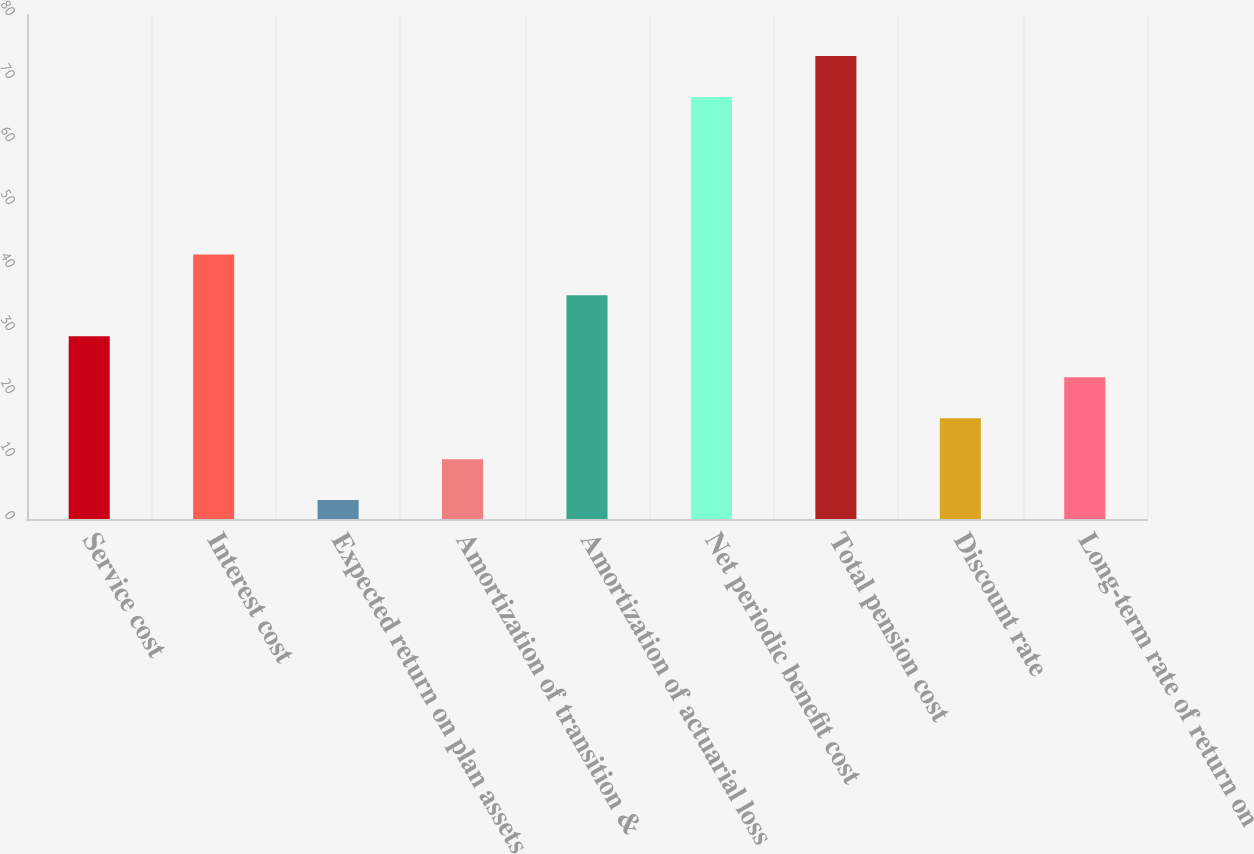<chart> <loc_0><loc_0><loc_500><loc_500><bar_chart><fcel>Service cost<fcel>Interest cost<fcel>Expected return on plan assets<fcel>Amortization of transition &<fcel>Amortization of actuarial loss<fcel>Net periodic benefit cost<fcel>Total pension cost<fcel>Discount rate<fcel>Long-term rate of return on<nl><fcel>29<fcel>42<fcel>3<fcel>9.5<fcel>35.5<fcel>67<fcel>73.5<fcel>16<fcel>22.5<nl></chart> 